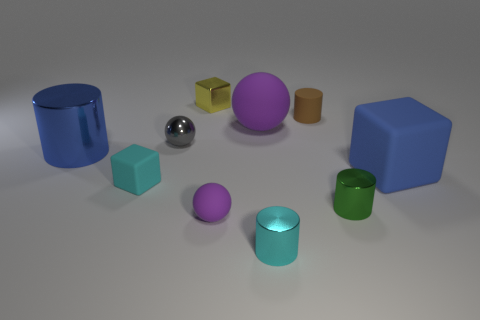What number of objects are matte cylinders or big purple balls?
Ensure brevity in your answer.  2. What shape is the tiny brown thing?
Make the answer very short. Cylinder. The brown object that is the same shape as the tiny green thing is what size?
Your response must be concise. Small. Is there anything else that has the same material as the tiny brown object?
Keep it short and to the point. Yes. What size is the purple ball in front of the rubber thing on the left side of the small purple object?
Provide a short and direct response. Small. Are there an equal number of purple things in front of the big purple rubber ball and matte objects?
Provide a succinct answer. No. What number of other things are the same color as the rubber cylinder?
Give a very brief answer. 0. Are there fewer small metal spheres on the left side of the gray object than small cubes?
Offer a very short reply. Yes. Are there any brown things of the same size as the blue cylinder?
Offer a very short reply. No. Do the metallic ball and the tiny thing that is on the right side of the small brown cylinder have the same color?
Provide a succinct answer. No. 